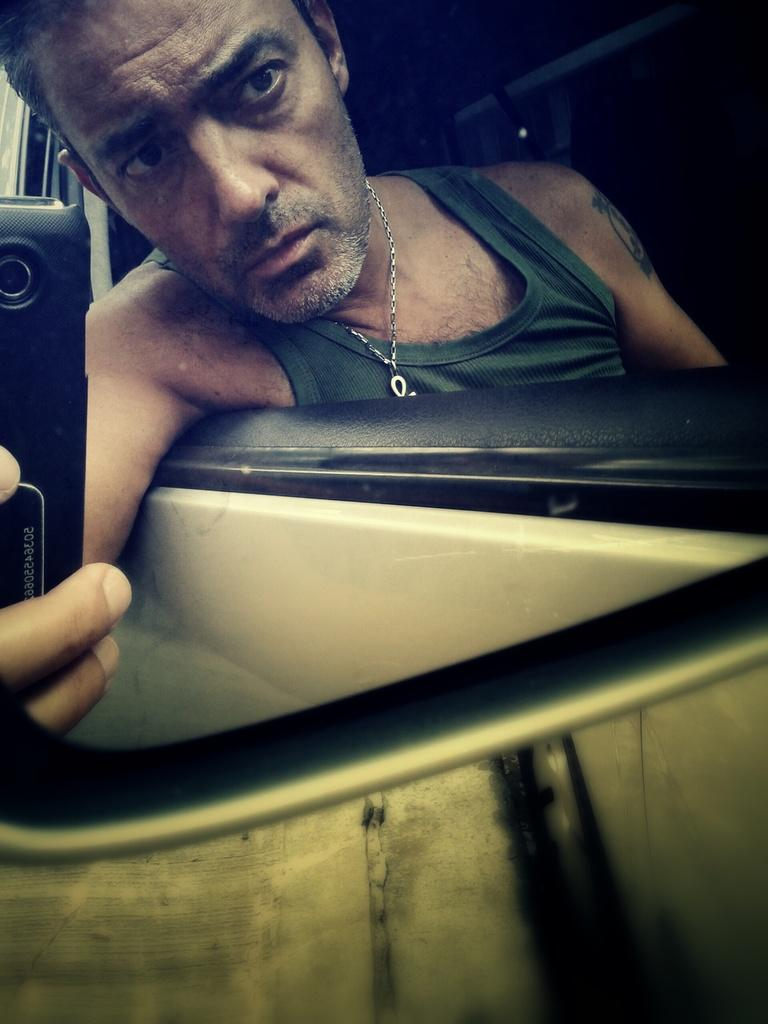What object in the image allows for reflection? There is a mirror in the image that allows for reflection. What is the man in the image holding? The man is holding a mobile in the image. Can you describe the man's appearance in the image? The man's reflection is visible in the mirror, but no specific details about his appearance are provided. What type of skin condition does the man have in the image? There is no information about the man's skin condition in the image. How many flies are visible in the image? There are no flies present in the image. 